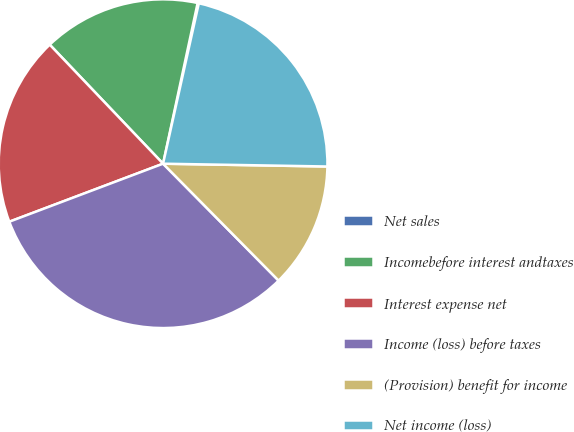<chart> <loc_0><loc_0><loc_500><loc_500><pie_chart><fcel>Net sales<fcel>Incomebefore interest andtaxes<fcel>Interest expense net<fcel>Income (loss) before taxes<fcel>(Provision) benefit for income<fcel>Net income (loss)<nl><fcel>0.12%<fcel>15.48%<fcel>18.63%<fcel>31.66%<fcel>12.32%<fcel>21.78%<nl></chart> 